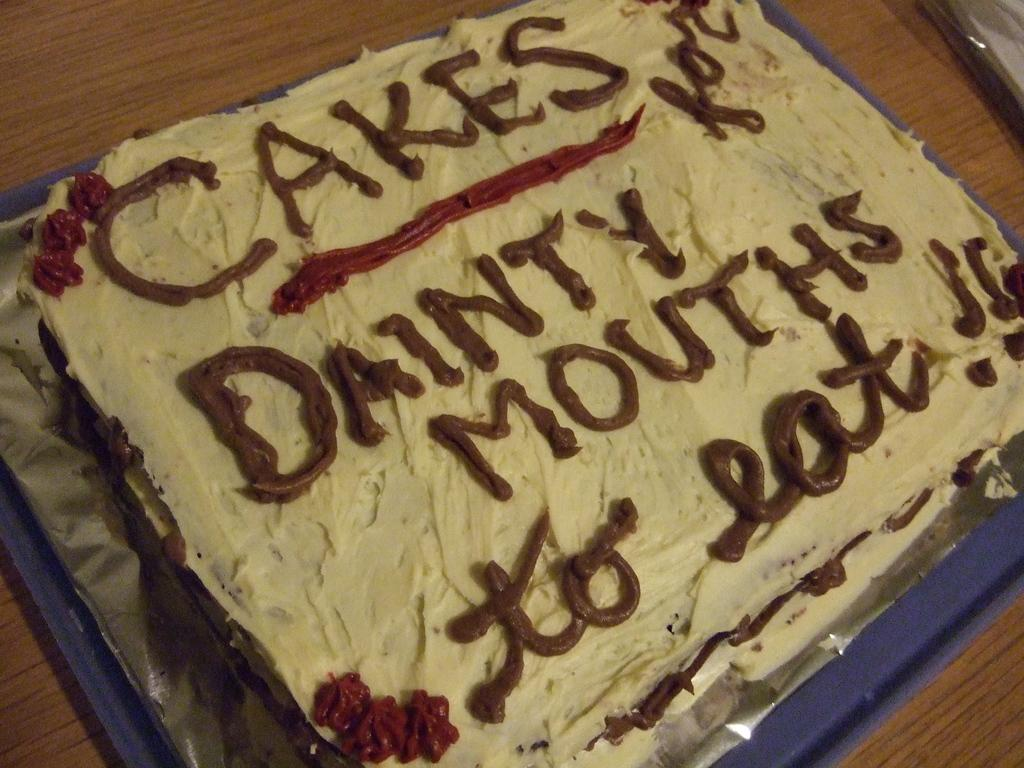What is the main subject of the image? There is a cake in the image. How is the cake being supported or displayed? The cake is on a tray. What additional detail can be seen on the cake? There is text on the cake. What piece of furniture is present in the image? There is a table in the image. What is the condition of the spoon in the image? There is no spoon present in the image. What type of surprise is hidden inside the cake? There is no indication of a surprise hidden inside the cake in the image. 